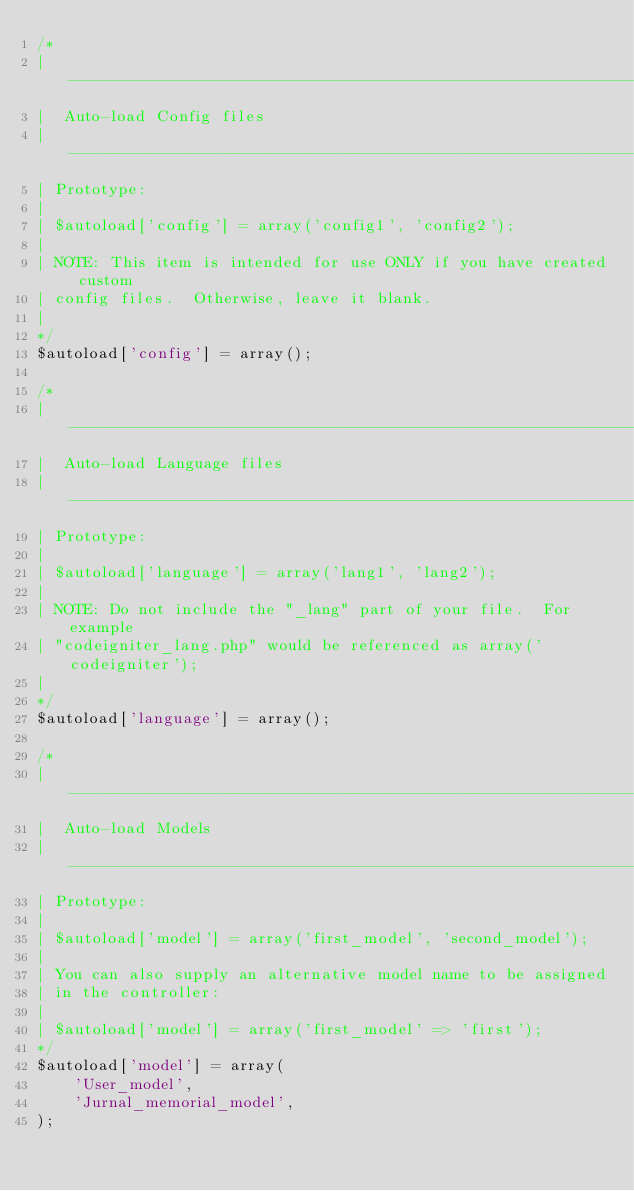<code> <loc_0><loc_0><loc_500><loc_500><_PHP_>/*
| -------------------------------------------------------------------
|  Auto-load Config files
| -------------------------------------------------------------------
| Prototype:
|
|	$autoload['config'] = array('config1', 'config2');
|
| NOTE: This item is intended for use ONLY if you have created custom
| config files.  Otherwise, leave it blank.
|
*/
$autoload['config'] = array();

/*
| -------------------------------------------------------------------
|  Auto-load Language files
| -------------------------------------------------------------------
| Prototype:
|
|	$autoload['language'] = array('lang1', 'lang2');
|
| NOTE: Do not include the "_lang" part of your file.  For example
| "codeigniter_lang.php" would be referenced as array('codeigniter');
|
*/
$autoload['language'] = array();

/*
| -------------------------------------------------------------------
|  Auto-load Models
| -------------------------------------------------------------------
| Prototype:
|
|	$autoload['model'] = array('first_model', 'second_model');
|
| You can also supply an alternative model name to be assigned
| in the controller:
|
|	$autoload['model'] = array('first_model' => 'first');
*/
$autoload['model'] = array(
    'User_model',
    'Jurnal_memorial_model',
);
</code> 